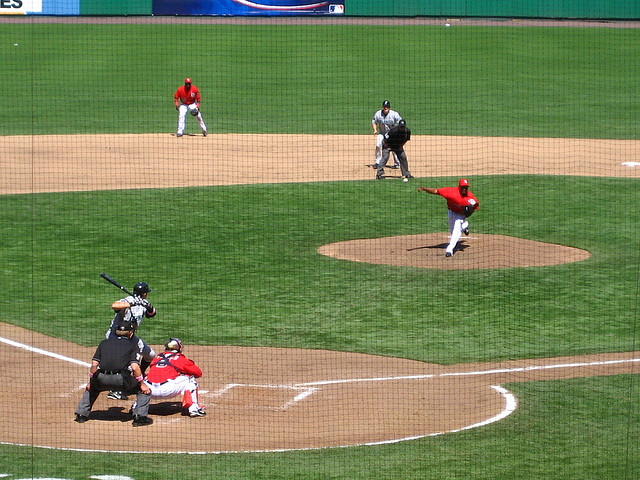What is happening in the image? The image captures a moment during a baseball game. The pitcher is in the midst of throwing the ball, likely aiming for a strike, while the batter is ready to swing. The catcher is crouched behind home plate, the umpire is observing the pitch, and two field players are positioned to field any balls hit into play. 